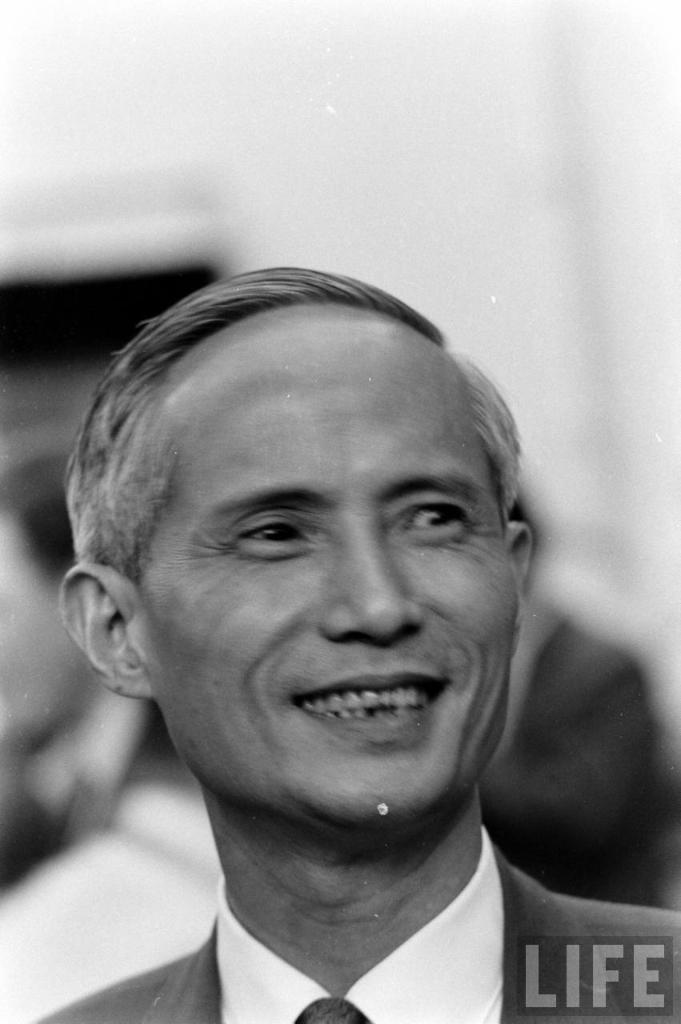Could you give a brief overview of what you see in this image? In the center of the image a man is present. In the background of the image some person are there. 